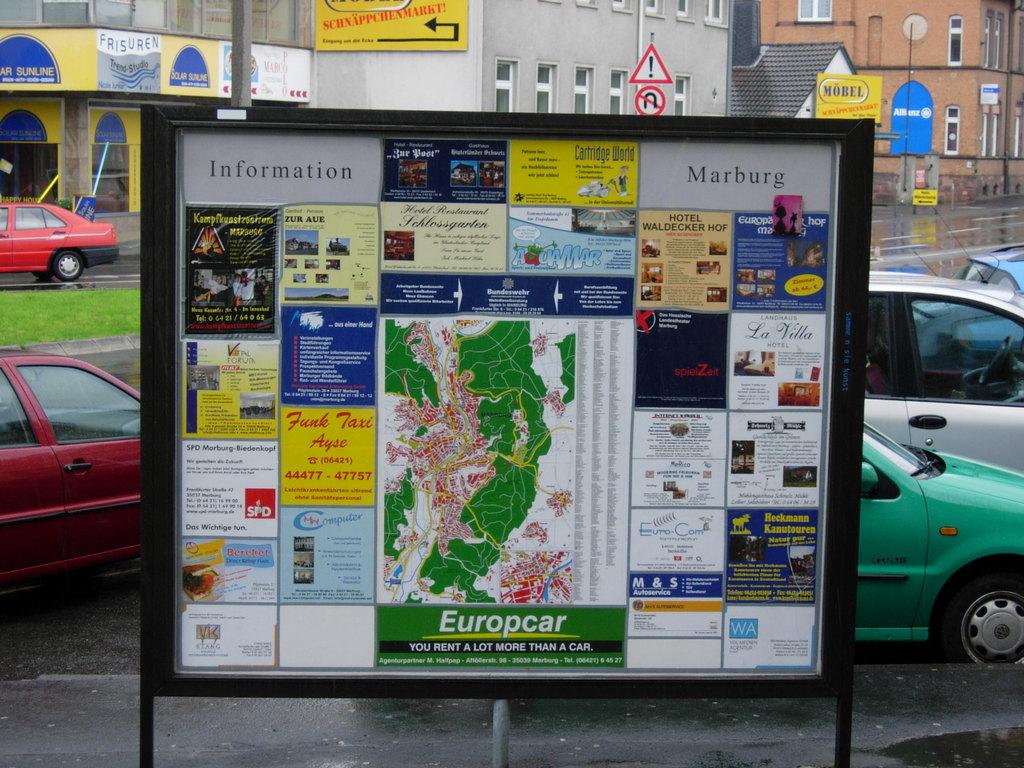What is this board meant to provide?
Provide a short and direct response. Information. What city is this in?
Offer a terse response. Marburg. 